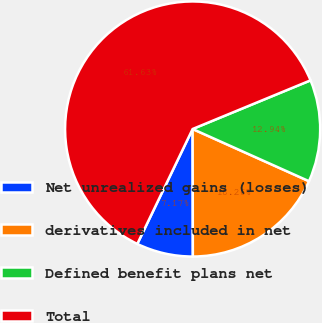Convert chart. <chart><loc_0><loc_0><loc_500><loc_500><pie_chart><fcel>Net unrealized gains (losses)<fcel>derivatives included in net<fcel>Defined benefit plans net<fcel>Total<nl><fcel>7.17%<fcel>18.26%<fcel>12.94%<fcel>61.63%<nl></chart> 